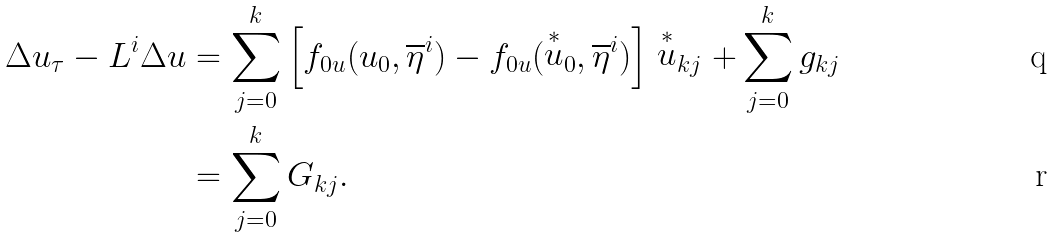<formula> <loc_0><loc_0><loc_500><loc_500>\Delta u _ { \tau } - L ^ { i } \Delta u & = \sum ^ { k } _ { j = 0 } \left [ f _ { 0 u } ( u _ { 0 } , \overline { \eta } ^ { i } ) - f _ { 0 u } ( \stackrel { * } { u } _ { 0 } , \overline { \eta } ^ { i } ) \right ] \stackrel { * } { u } _ { k j } + \sum ^ { k } _ { j = 0 } g _ { k j } \\ & = \sum ^ { k } _ { j = 0 } G _ { k j } .</formula> 